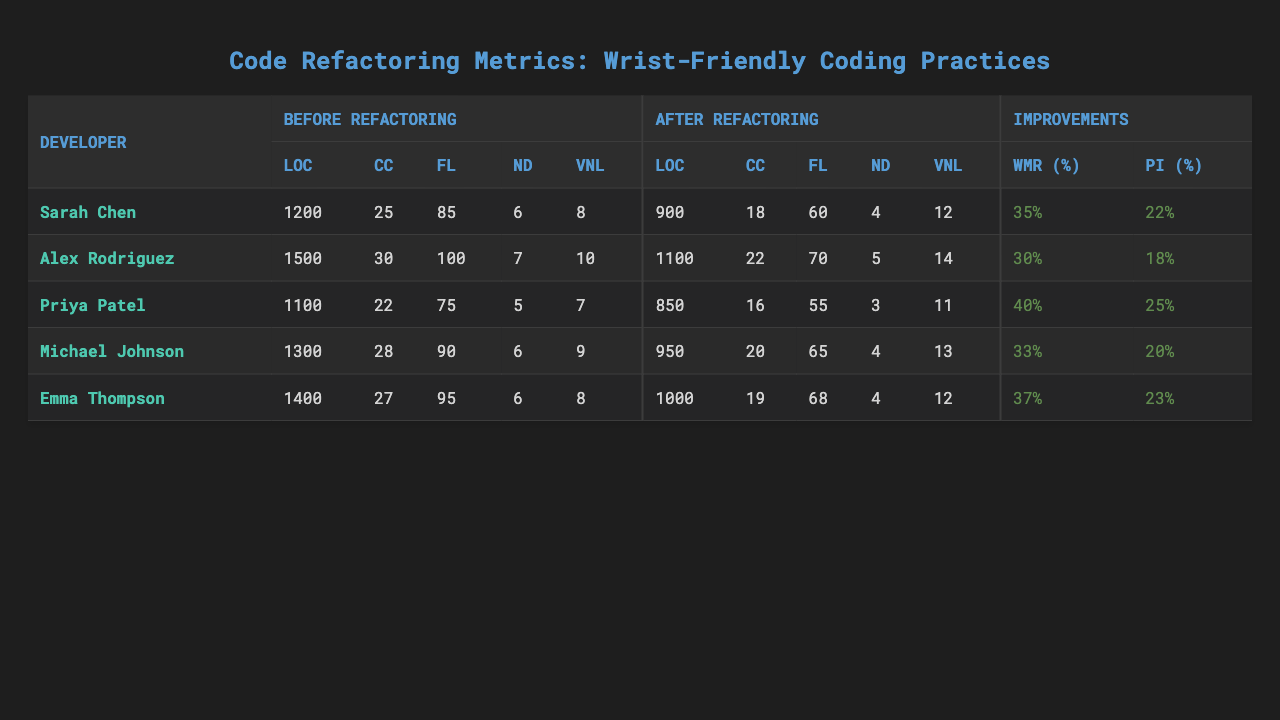What is the reduction percentage for Priya Patel? Looking at the "Wrist Movement Reduction" section, the reduction percentage for Priya Patel is listed as 40%.
Answer: 40% What was Emma Thompson's Cyclomatic Complexity before refactoring? In the "Before Refactoring" section under Cyclomatic Complexity for Emma Thompson, the value is 27.
Answer: 27 Which developer had the highest Lines of Code after refactoring? In the "After Refactoring" section, I review the Lines of Code for each developer. Emma Thompson has the highest value at 1000.
Answer: 1000 What is the average Function Length for developers before refactoring? I need to add the Function Length values before refactoring (85 + 100 + 75 + 90 + 95 = 445) and divide by the number of developers (5), resulting in an average of 445 / 5 = 89.
Answer: 89 Did Sarah Chen experience an increase in productivity after refactoring? By checking the "Productivity Increase" section for Sarah Chen, it shows an increase of 22%. Therefore, she did experience an increase.
Answer: Yes Which developer had the lowest nesting depth after refactoring? Reviewing the "After Refactoring" section under Nesting Depth reveals that Priya Patel has the lowest value at 3.
Answer: 3 What was the change in Variable Name Length for Michael Johnson after refactoring? I check the "Before Refactoring" Variable Name Length for Michael Johnson, which is 9, and the "After Refactoring" variable, which is 13. The change is 13 - 9 = 4.
Answer: 4 What percentage did Alex Rodriguez's Cyclomatic Complexity reduce by after refactoring? Before refactoring, Alex Rodriguez's Cyclomatic Complexity is 30 and after it's 22. The reduction is (30 - 22) / 30 * 100 = 26.67%.
Answer: 26.67% How many developers had a Lines of Code reduction greater than 300? I look at the Lines of Code before (e.g., 1200, 1500, etc.) and after (e.g., 900, 1100, etc.) refactoring for each developer. The reductions are: Sarah Chen (300), Alex Rodriguez (400), Priya Patel (250), Michael Johnson (350), Emma Thompson (400). Hence, three developers (Alex, Michael, and Emma) had a reduction greater than 300.
Answer: 3 Is it true that every developer increased their productivity after the refactoring process? By checking the "Productivity Increase" values for all developers, I see they all have positive increase percentages, confirming that each one did increase productivity.
Answer: Yes 